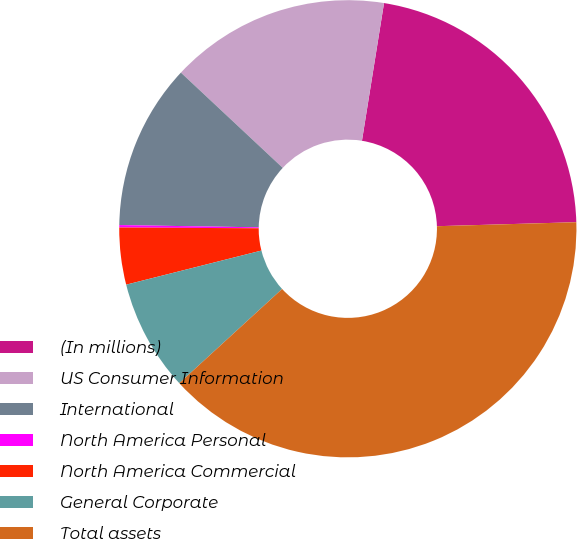<chart> <loc_0><loc_0><loc_500><loc_500><pie_chart><fcel>(In millions)<fcel>US Consumer Information<fcel>International<fcel>North America Personal<fcel>North America Commercial<fcel>General Corporate<fcel>Total assets<nl><fcel>22.01%<fcel>15.56%<fcel>11.71%<fcel>0.17%<fcel>4.02%<fcel>7.87%<fcel>38.65%<nl></chart> 